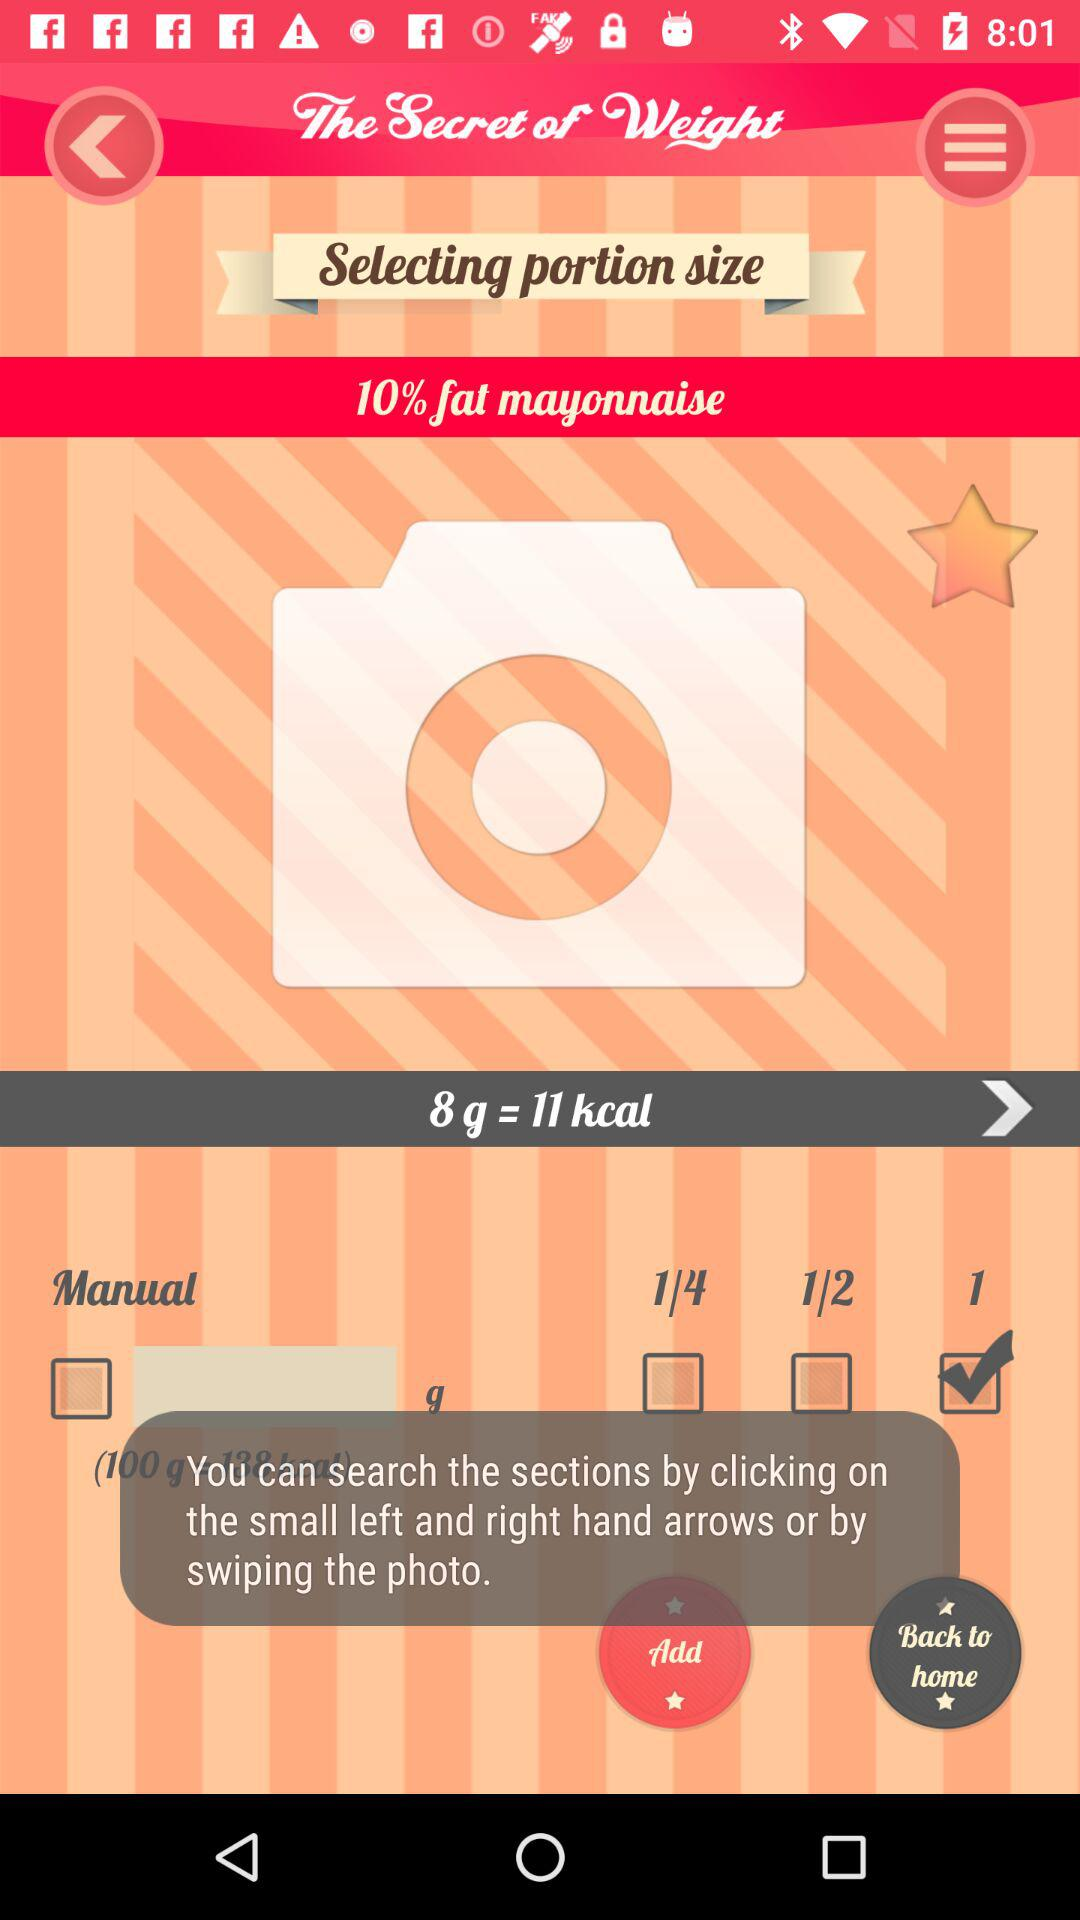What is the % of fat in mayonnaise? In mayonnaise, there is 10% fat. 